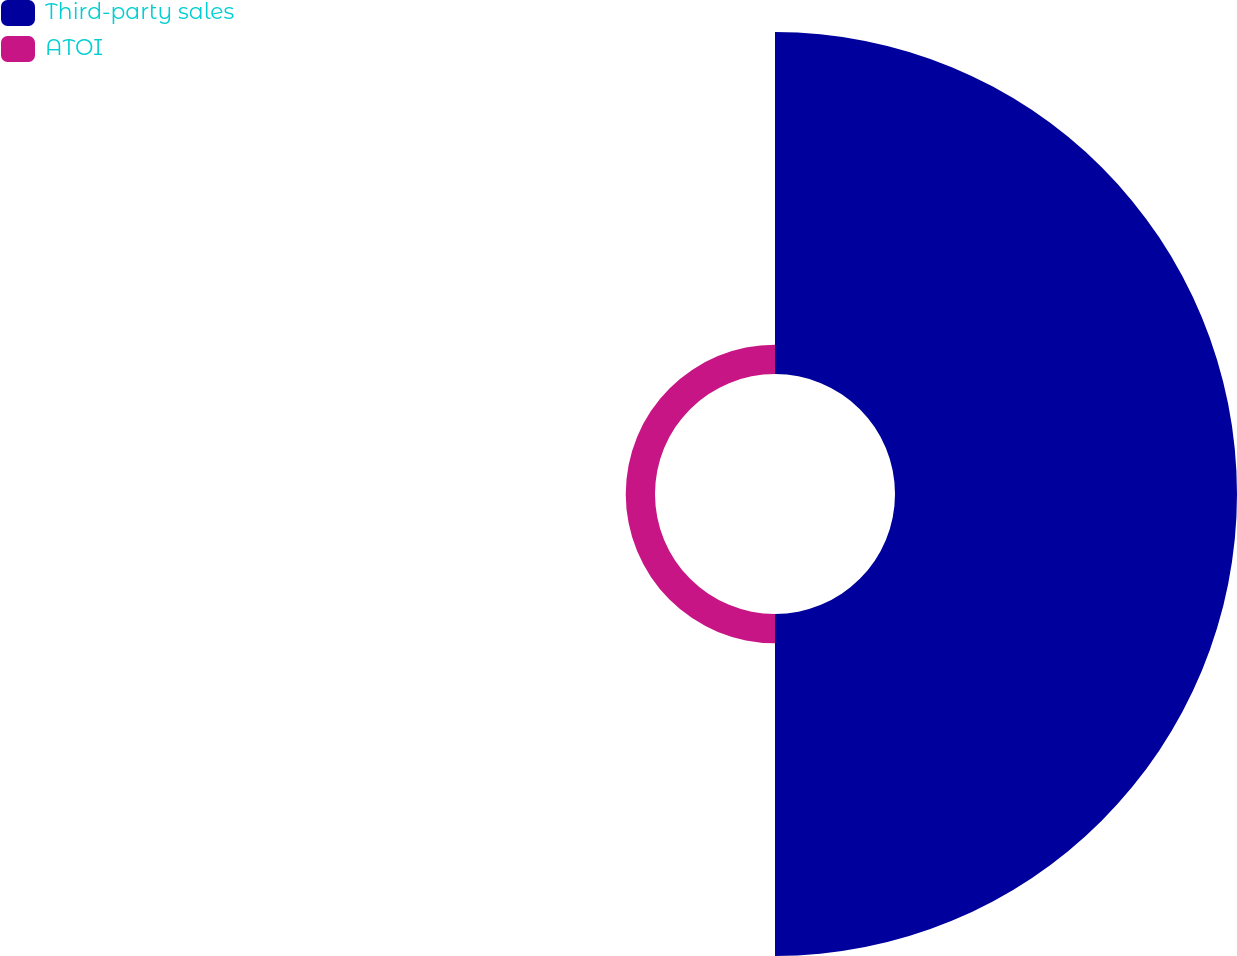<chart> <loc_0><loc_0><loc_500><loc_500><pie_chart><fcel>Third-party sales<fcel>ATOI<nl><fcel>92.12%<fcel>7.88%<nl></chart> 